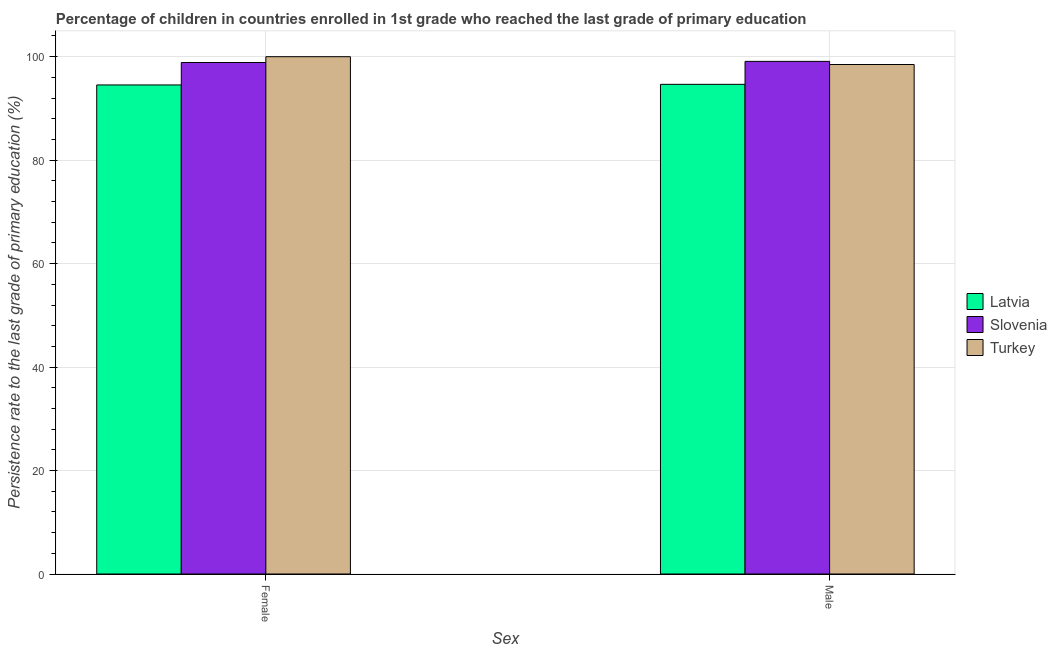How many different coloured bars are there?
Provide a short and direct response. 3. How many groups of bars are there?
Your answer should be compact. 2. Are the number of bars per tick equal to the number of legend labels?
Keep it short and to the point. Yes. How many bars are there on the 2nd tick from the left?
Your answer should be very brief. 3. How many bars are there on the 1st tick from the right?
Provide a short and direct response. 3. What is the persistence rate of female students in Slovenia?
Provide a succinct answer. 98.88. Across all countries, what is the maximum persistence rate of male students?
Your answer should be very brief. 99.1. Across all countries, what is the minimum persistence rate of male students?
Offer a very short reply. 94.66. In which country was the persistence rate of female students minimum?
Offer a terse response. Latvia. What is the total persistence rate of male students in the graph?
Make the answer very short. 292.24. What is the difference between the persistence rate of male students in Latvia and that in Slovenia?
Offer a very short reply. -4.44. What is the difference between the persistence rate of male students in Turkey and the persistence rate of female students in Latvia?
Make the answer very short. 3.95. What is the average persistence rate of male students per country?
Provide a succinct answer. 97.41. What is the difference between the persistence rate of male students and persistence rate of female students in Turkey?
Provide a short and direct response. -1.51. In how many countries, is the persistence rate of male students greater than 36 %?
Offer a terse response. 3. What is the ratio of the persistence rate of male students in Latvia to that in Turkey?
Ensure brevity in your answer.  0.96. What does the 2nd bar from the left in Male represents?
Offer a terse response. Slovenia. Are all the bars in the graph horizontal?
Keep it short and to the point. No. Does the graph contain any zero values?
Provide a short and direct response. No. Where does the legend appear in the graph?
Make the answer very short. Center right. How are the legend labels stacked?
Give a very brief answer. Vertical. What is the title of the graph?
Keep it short and to the point. Percentage of children in countries enrolled in 1st grade who reached the last grade of primary education. What is the label or title of the X-axis?
Offer a very short reply. Sex. What is the label or title of the Y-axis?
Offer a terse response. Persistence rate to the last grade of primary education (%). What is the Persistence rate to the last grade of primary education (%) of Latvia in Female?
Offer a terse response. 94.54. What is the Persistence rate to the last grade of primary education (%) in Slovenia in Female?
Keep it short and to the point. 98.88. What is the Persistence rate to the last grade of primary education (%) in Turkey in Female?
Offer a very short reply. 100. What is the Persistence rate to the last grade of primary education (%) in Latvia in Male?
Ensure brevity in your answer.  94.66. What is the Persistence rate to the last grade of primary education (%) in Slovenia in Male?
Your answer should be compact. 99.1. What is the Persistence rate to the last grade of primary education (%) of Turkey in Male?
Your answer should be very brief. 98.49. Across all Sex, what is the maximum Persistence rate to the last grade of primary education (%) of Latvia?
Ensure brevity in your answer.  94.66. Across all Sex, what is the maximum Persistence rate to the last grade of primary education (%) of Slovenia?
Offer a very short reply. 99.1. Across all Sex, what is the minimum Persistence rate to the last grade of primary education (%) of Latvia?
Your answer should be very brief. 94.54. Across all Sex, what is the minimum Persistence rate to the last grade of primary education (%) in Slovenia?
Provide a short and direct response. 98.88. Across all Sex, what is the minimum Persistence rate to the last grade of primary education (%) in Turkey?
Give a very brief answer. 98.49. What is the total Persistence rate to the last grade of primary education (%) of Latvia in the graph?
Offer a very short reply. 189.19. What is the total Persistence rate to the last grade of primary education (%) in Slovenia in the graph?
Your answer should be compact. 197.97. What is the total Persistence rate to the last grade of primary education (%) in Turkey in the graph?
Make the answer very short. 198.49. What is the difference between the Persistence rate to the last grade of primary education (%) in Latvia in Female and that in Male?
Give a very brief answer. -0.12. What is the difference between the Persistence rate to the last grade of primary education (%) of Slovenia in Female and that in Male?
Make the answer very short. -0.22. What is the difference between the Persistence rate to the last grade of primary education (%) in Turkey in Female and that in Male?
Offer a very short reply. 1.51. What is the difference between the Persistence rate to the last grade of primary education (%) of Latvia in Female and the Persistence rate to the last grade of primary education (%) of Slovenia in Male?
Keep it short and to the point. -4.56. What is the difference between the Persistence rate to the last grade of primary education (%) of Latvia in Female and the Persistence rate to the last grade of primary education (%) of Turkey in Male?
Make the answer very short. -3.95. What is the difference between the Persistence rate to the last grade of primary education (%) in Slovenia in Female and the Persistence rate to the last grade of primary education (%) in Turkey in Male?
Provide a succinct answer. 0.39. What is the average Persistence rate to the last grade of primary education (%) of Latvia per Sex?
Provide a succinct answer. 94.6. What is the average Persistence rate to the last grade of primary education (%) of Slovenia per Sex?
Your response must be concise. 98.99. What is the average Persistence rate to the last grade of primary education (%) in Turkey per Sex?
Your answer should be very brief. 99.24. What is the difference between the Persistence rate to the last grade of primary education (%) in Latvia and Persistence rate to the last grade of primary education (%) in Slovenia in Female?
Offer a terse response. -4.34. What is the difference between the Persistence rate to the last grade of primary education (%) of Latvia and Persistence rate to the last grade of primary education (%) of Turkey in Female?
Give a very brief answer. -5.46. What is the difference between the Persistence rate to the last grade of primary education (%) in Slovenia and Persistence rate to the last grade of primary education (%) in Turkey in Female?
Provide a succinct answer. -1.12. What is the difference between the Persistence rate to the last grade of primary education (%) of Latvia and Persistence rate to the last grade of primary education (%) of Slovenia in Male?
Provide a short and direct response. -4.44. What is the difference between the Persistence rate to the last grade of primary education (%) in Latvia and Persistence rate to the last grade of primary education (%) in Turkey in Male?
Offer a terse response. -3.83. What is the difference between the Persistence rate to the last grade of primary education (%) of Slovenia and Persistence rate to the last grade of primary education (%) of Turkey in Male?
Provide a short and direct response. 0.61. What is the ratio of the Persistence rate to the last grade of primary education (%) in Turkey in Female to that in Male?
Your answer should be compact. 1.02. What is the difference between the highest and the second highest Persistence rate to the last grade of primary education (%) in Latvia?
Your answer should be very brief. 0.12. What is the difference between the highest and the second highest Persistence rate to the last grade of primary education (%) of Slovenia?
Ensure brevity in your answer.  0.22. What is the difference between the highest and the second highest Persistence rate to the last grade of primary education (%) in Turkey?
Offer a very short reply. 1.51. What is the difference between the highest and the lowest Persistence rate to the last grade of primary education (%) of Latvia?
Keep it short and to the point. 0.12. What is the difference between the highest and the lowest Persistence rate to the last grade of primary education (%) of Slovenia?
Make the answer very short. 0.22. What is the difference between the highest and the lowest Persistence rate to the last grade of primary education (%) in Turkey?
Your response must be concise. 1.51. 